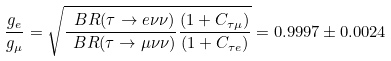<formula> <loc_0><loc_0><loc_500><loc_500>\frac { g _ { e } } { g _ { \mu } } = \sqrt { \frac { \ B R ( \tau \to e \nu \nu ) } { \ B R ( \tau \to \mu \nu \nu ) } \frac { ( 1 + C _ { \tau \mu } ) } { ( 1 + C _ { \tau e } ) } } = 0 . 9 9 9 7 \pm 0 . 0 0 2 4</formula> 